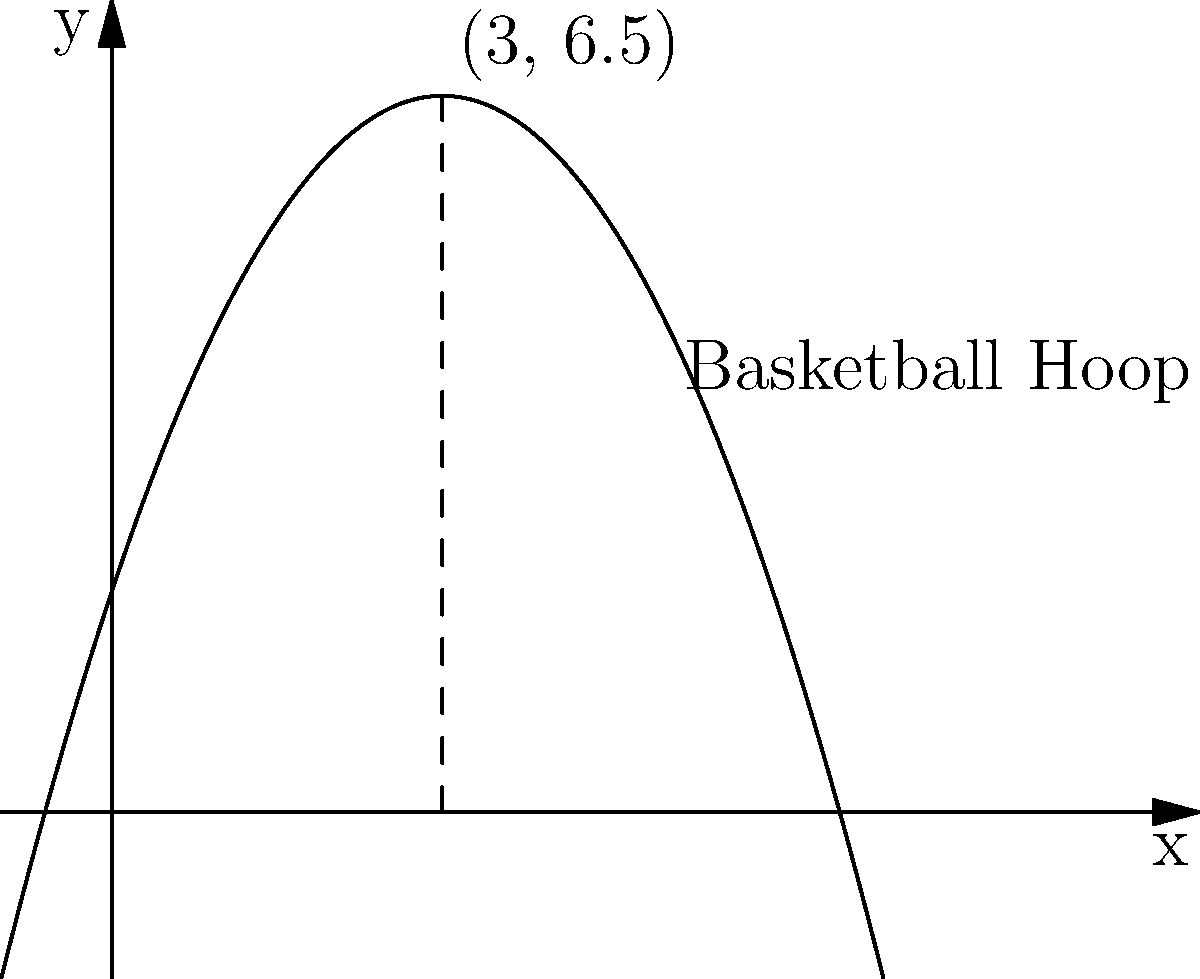In a game of Pleasant Goat and Big Big Wolf basketball, Weslie throws a ball that follows a parabolic path described by the function $f(x) = -0.5x^2 + 3x + 2$, where $x$ is the horizontal distance and $f(x)$ is the height, both measured in meters. What is the maximum height reached by the ball, and at what horizontal distance does this occur? To find the maximum height of the parabolic curve, we need to follow these steps:

1) The general form of a quadratic function is $f(x) = ax^2 + bx + c$, where $a$, $b$, and $c$ are constants and $a ≠ 0$.

2) In our case, $a = -0.5$, $b = 3$, and $c = 2$.

3) For a quadratic function, the x-coordinate of the vertex (which gives the maximum or minimum point) is given by the formula: $x = -\frac{b}{2a}$

4) Substituting our values:
   $x = -\frac{3}{2(-0.5)} = \frac{3}{-1} = 3$

5) To find the y-coordinate (the maximum height), we substitute this x-value back into our original function:

   $f(3) = -0.5(3)^2 + 3(3) + 2$
         $= -0.5(9) + 9 + 2$
         $= -4.5 + 9 + 2$
         $= 6.5$

6) Therefore, the maximum point occurs at (3, 6.5).

The ball reaches its maximum height of 6.5 meters when it's 3 meters away horizontally from the starting point.
Answer: Maximum height: 6.5 meters, occurs at x = 3 meters 